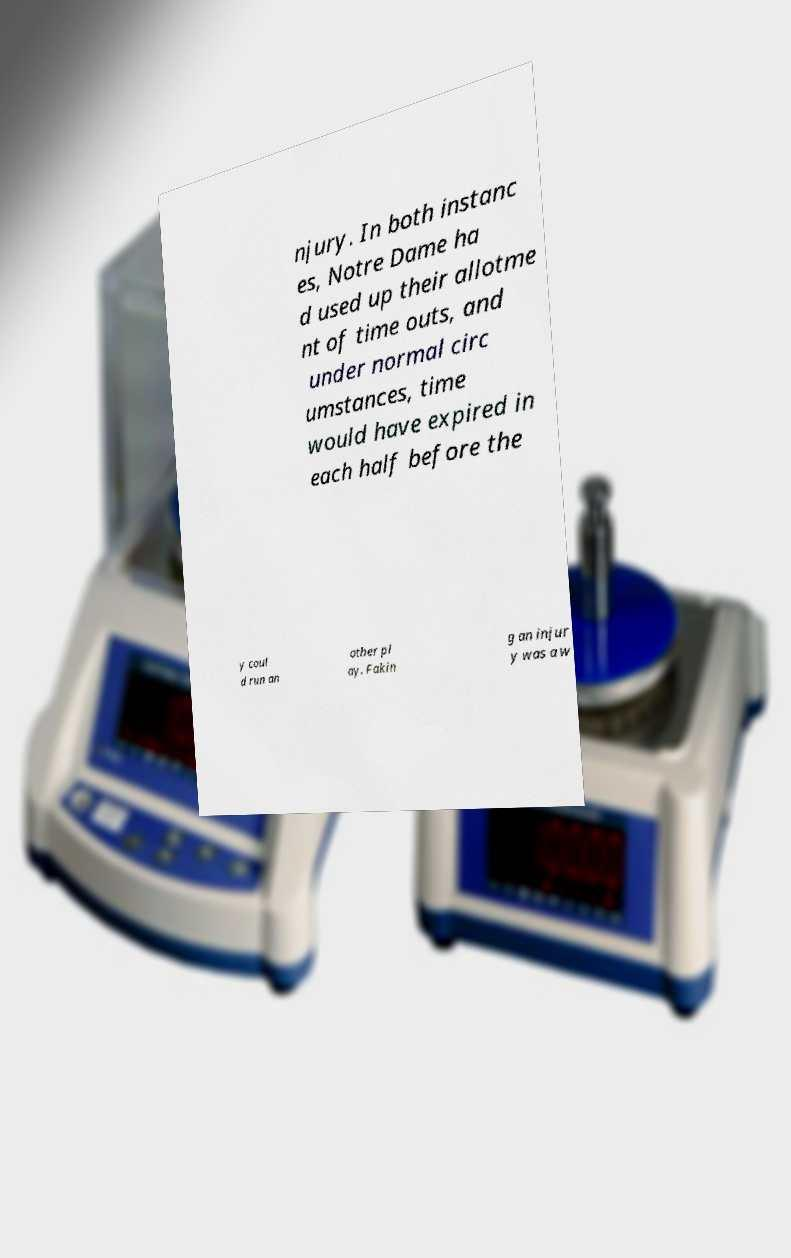For documentation purposes, I need the text within this image transcribed. Could you provide that? njury. In both instanc es, Notre Dame ha d used up their allotme nt of time outs, and under normal circ umstances, time would have expired in each half before the y coul d run an other pl ay. Fakin g an injur y was a w 